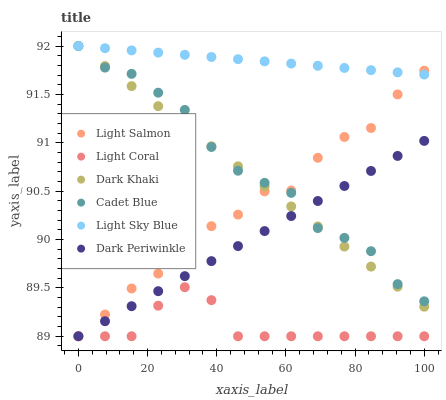Does Light Coral have the minimum area under the curve?
Answer yes or no. Yes. Does Light Sky Blue have the maximum area under the curve?
Answer yes or no. Yes. Does Light Salmon have the minimum area under the curve?
Answer yes or no. No. Does Light Salmon have the maximum area under the curve?
Answer yes or no. No. Is Dark Periwinkle the smoothest?
Answer yes or no. Yes. Is Cadet Blue the roughest?
Answer yes or no. Yes. Is Light Salmon the smoothest?
Answer yes or no. No. Is Light Salmon the roughest?
Answer yes or no. No. Does Light Salmon have the lowest value?
Answer yes or no. Yes. Does Cadet Blue have the lowest value?
Answer yes or no. No. Does Light Sky Blue have the highest value?
Answer yes or no. Yes. Does Light Salmon have the highest value?
Answer yes or no. No. Is Light Coral less than Cadet Blue?
Answer yes or no. Yes. Is Cadet Blue greater than Light Coral?
Answer yes or no. Yes. Does Light Salmon intersect Light Coral?
Answer yes or no. Yes. Is Light Salmon less than Light Coral?
Answer yes or no. No. Is Light Salmon greater than Light Coral?
Answer yes or no. No. Does Light Coral intersect Cadet Blue?
Answer yes or no. No. 